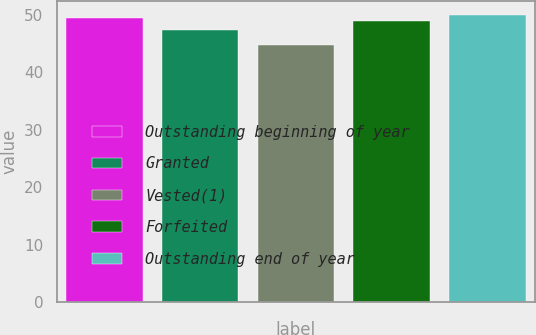Convert chart. <chart><loc_0><loc_0><loc_500><loc_500><bar_chart><fcel>Outstanding beginning of year<fcel>Granted<fcel>Vested(1)<fcel>Forfeited<fcel>Outstanding end of year<nl><fcel>49.38<fcel>47.31<fcel>44.8<fcel>48.87<fcel>49.89<nl></chart> 